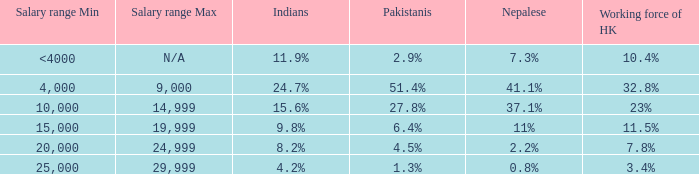If the nepalese is 37.1%, what is the working force of HK? 23%. 